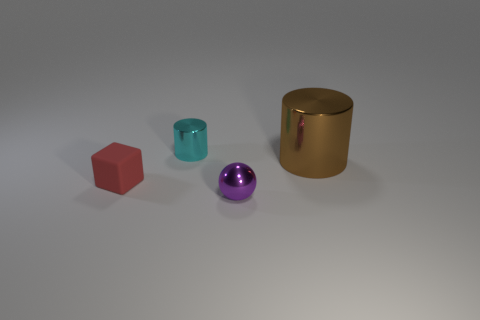The objects seem to have different materials; what do they look like they're made of? The red cube appears to be matte and likely made of a plastic material. The teal cylinder also has a matte finish, suggesting a similar plastic composition. In contrast, the purple sphere has a glossy, metallic finish which catches the light, whereas the large gold cylinder has a brushed metal surface, indicative of a metallic structure as well. 